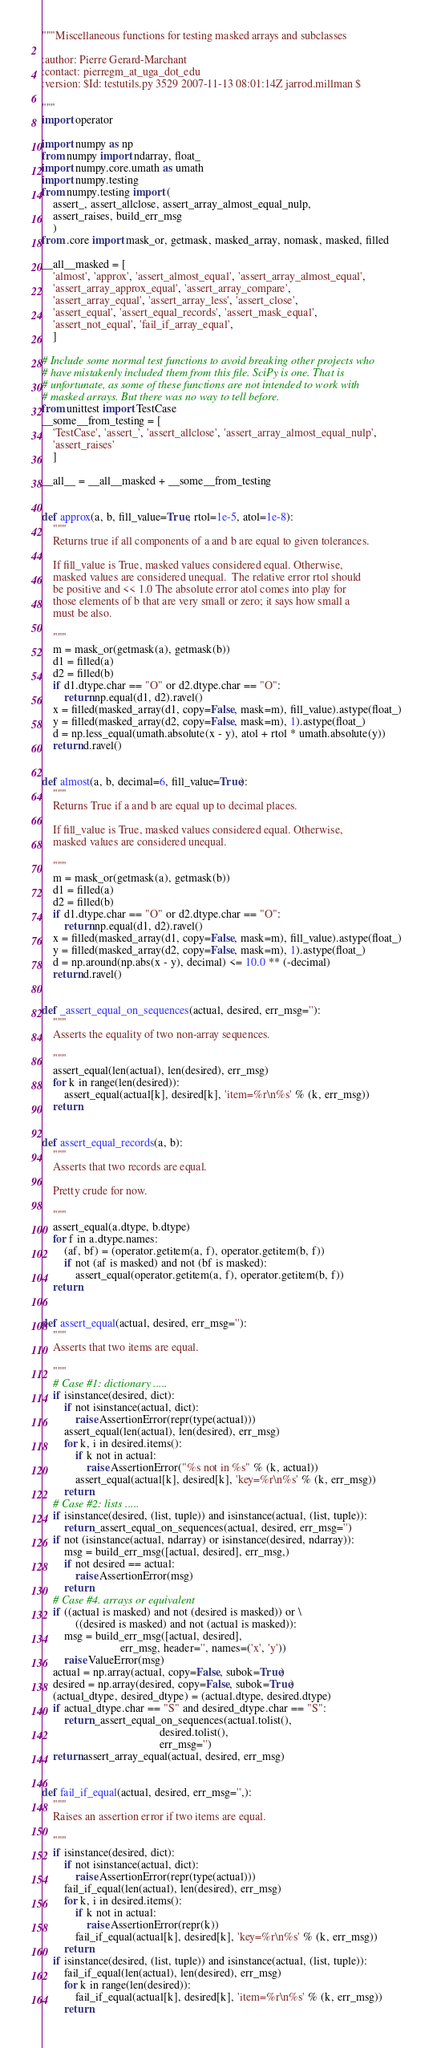Convert code to text. <code><loc_0><loc_0><loc_500><loc_500><_Python_>"""Miscellaneous functions for testing masked arrays and subclasses

:author: Pierre Gerard-Marchant
:contact: pierregm_at_uga_dot_edu
:version: $Id: testutils.py 3529 2007-11-13 08:01:14Z jarrod.millman $

"""
import operator

import numpy as np
from numpy import ndarray, float_
import numpy.core.umath as umath
import numpy.testing
from numpy.testing import (
    assert_, assert_allclose, assert_array_almost_equal_nulp,
    assert_raises, build_err_msg
    )
from .core import mask_or, getmask, masked_array, nomask, masked, filled

__all__masked = [
    'almost', 'approx', 'assert_almost_equal', 'assert_array_almost_equal',
    'assert_array_approx_equal', 'assert_array_compare',
    'assert_array_equal', 'assert_array_less', 'assert_close',
    'assert_equal', 'assert_equal_records', 'assert_mask_equal',
    'assert_not_equal', 'fail_if_array_equal',
    ]

# Include some normal test functions to avoid breaking other projects who
# have mistakenly included them from this file. SciPy is one. That is
# unfortunate, as some of these functions are not intended to work with
# masked arrays. But there was no way to tell before.
from unittest import TestCase
__some__from_testing = [
    'TestCase', 'assert_', 'assert_allclose', 'assert_array_almost_equal_nulp',
    'assert_raises'
    ]

__all__ = __all__masked + __some__from_testing


def approx(a, b, fill_value=True, rtol=1e-5, atol=1e-8):
    """
    Returns true if all components of a and b are equal to given tolerances.

    If fill_value is True, masked values considered equal. Otherwise,
    masked values are considered unequal.  The relative error rtol should
    be positive and << 1.0 The absolute error atol comes into play for
    those elements of b that are very small or zero; it says how small a
    must be also.

    """
    m = mask_or(getmask(a), getmask(b))
    d1 = filled(a)
    d2 = filled(b)
    if d1.dtype.char == "O" or d2.dtype.char == "O":
        return np.equal(d1, d2).ravel()
    x = filled(masked_array(d1, copy=False, mask=m), fill_value).astype(float_)
    y = filled(masked_array(d2, copy=False, mask=m), 1).astype(float_)
    d = np.less_equal(umath.absolute(x - y), atol + rtol * umath.absolute(y))
    return d.ravel()


def almost(a, b, decimal=6, fill_value=True):
    """
    Returns True if a and b are equal up to decimal places.

    If fill_value is True, masked values considered equal. Otherwise,
    masked values are considered unequal.

    """
    m = mask_or(getmask(a), getmask(b))
    d1 = filled(a)
    d2 = filled(b)
    if d1.dtype.char == "O" or d2.dtype.char == "O":
        return np.equal(d1, d2).ravel()
    x = filled(masked_array(d1, copy=False, mask=m), fill_value).astype(float_)
    y = filled(masked_array(d2, copy=False, mask=m), 1).astype(float_)
    d = np.around(np.abs(x - y), decimal) <= 10.0 ** (-decimal)
    return d.ravel()


def _assert_equal_on_sequences(actual, desired, err_msg=''):
    """
    Asserts the equality of two non-array sequences.

    """
    assert_equal(len(actual), len(desired), err_msg)
    for k in range(len(desired)):
        assert_equal(actual[k], desired[k], 'item=%r\n%s' % (k, err_msg))
    return


def assert_equal_records(a, b):
    """
    Asserts that two records are equal.

    Pretty crude for now.

    """
    assert_equal(a.dtype, b.dtype)
    for f in a.dtype.names:
        (af, bf) = (operator.getitem(a, f), operator.getitem(b, f))
        if not (af is masked) and not (bf is masked):
            assert_equal(operator.getitem(a, f), operator.getitem(b, f))
    return


def assert_equal(actual, desired, err_msg=''):
    """
    Asserts that two items are equal.

    """
    # Case #1: dictionary .....
    if isinstance(desired, dict):
        if not isinstance(actual, dict):
            raise AssertionError(repr(type(actual)))
        assert_equal(len(actual), len(desired), err_msg)
        for k, i in desired.items():
            if k not in actual:
                raise AssertionError("%s not in %s" % (k, actual))
            assert_equal(actual[k], desired[k], 'key=%r\n%s' % (k, err_msg))
        return
    # Case #2: lists .....
    if isinstance(desired, (list, tuple)) and isinstance(actual, (list, tuple)):
        return _assert_equal_on_sequences(actual, desired, err_msg='')
    if not (isinstance(actual, ndarray) or isinstance(desired, ndarray)):
        msg = build_err_msg([actual, desired], err_msg,)
        if not desired == actual:
            raise AssertionError(msg)
        return
    # Case #4. arrays or equivalent
    if ((actual is masked) and not (desired is masked)) or \
            ((desired is masked) and not (actual is masked)):
        msg = build_err_msg([actual, desired],
                            err_msg, header='', names=('x', 'y'))
        raise ValueError(msg)
    actual = np.array(actual, copy=False, subok=True)
    desired = np.array(desired, copy=False, subok=True)
    (actual_dtype, desired_dtype) = (actual.dtype, desired.dtype)
    if actual_dtype.char == "S" and desired_dtype.char == "S":
        return _assert_equal_on_sequences(actual.tolist(),
                                          desired.tolist(),
                                          err_msg='')
    return assert_array_equal(actual, desired, err_msg)


def fail_if_equal(actual, desired, err_msg='',):
    """
    Raises an assertion error if two items are equal.

    """
    if isinstance(desired, dict):
        if not isinstance(actual, dict):
            raise AssertionError(repr(type(actual)))
        fail_if_equal(len(actual), len(desired), err_msg)
        for k, i in desired.items():
            if k not in actual:
                raise AssertionError(repr(k))
            fail_if_equal(actual[k], desired[k], 'key=%r\n%s' % (k, err_msg))
        return
    if isinstance(desired, (list, tuple)) and isinstance(actual, (list, tuple)):
        fail_if_equal(len(actual), len(desired), err_msg)
        for k in range(len(desired)):
            fail_if_equal(actual[k], desired[k], 'item=%r\n%s' % (k, err_msg))
        return</code> 